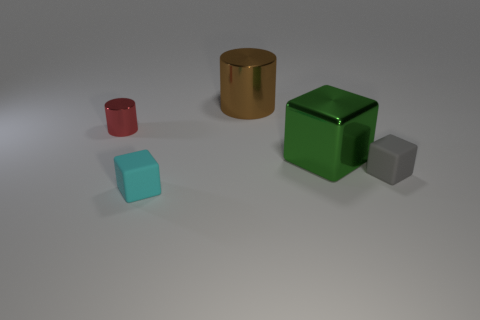What is the color of the big object that is behind the metallic thing that is to the left of the small matte thing that is on the left side of the gray cube?
Make the answer very short. Brown. What number of other objects are the same size as the brown object?
Ensure brevity in your answer.  1. Are there any other things that are the same shape as the big brown metallic thing?
Keep it short and to the point. Yes. There is another matte object that is the same shape as the gray matte object; what color is it?
Your response must be concise. Cyan. There is another thing that is made of the same material as the tiny cyan object; what is its color?
Provide a succinct answer. Gray. Are there an equal number of small metallic cylinders that are to the right of the green object and red shiny cylinders?
Offer a terse response. No. Is the size of the cyan object that is in front of the brown cylinder the same as the small metallic cylinder?
Your answer should be very brief. Yes. There is another matte object that is the same size as the cyan matte thing; what is its color?
Provide a short and direct response. Gray. There is a rubber cube left of the large thing that is in front of the big brown cylinder; are there any metal objects to the left of it?
Your answer should be compact. Yes. What is the cylinder behind the red shiny cylinder made of?
Ensure brevity in your answer.  Metal. 